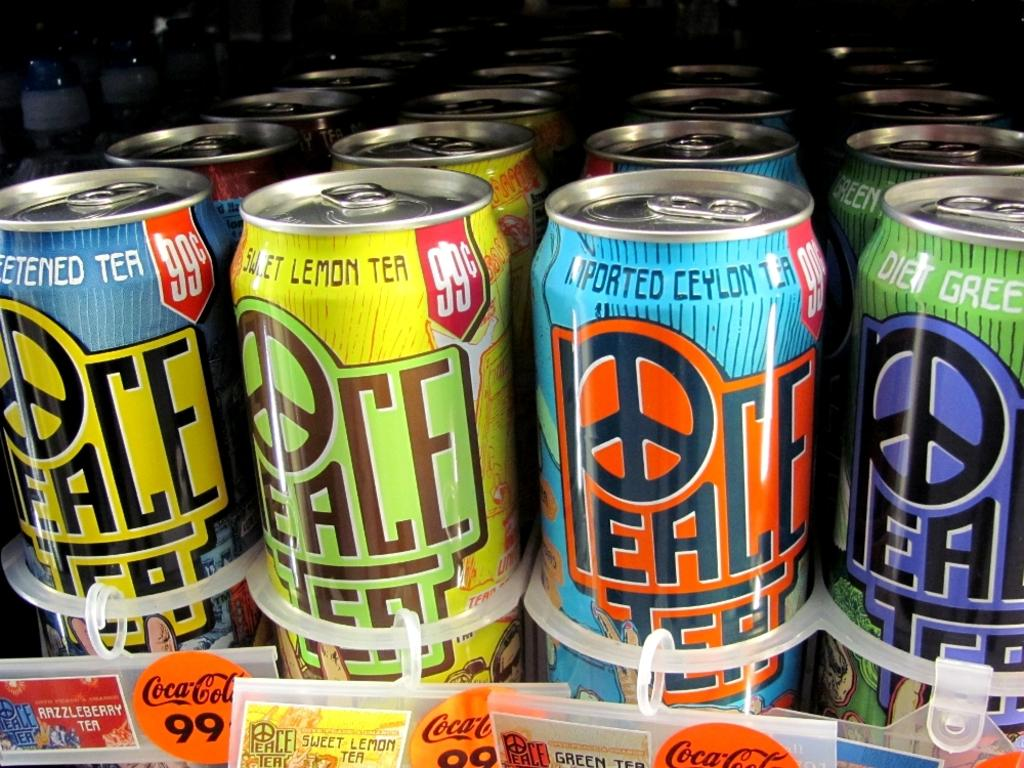Provide a one-sentence caption for the provided image. Brightly decorated cans of peace tea in multi-flavors. 